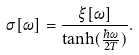<formula> <loc_0><loc_0><loc_500><loc_500>\sigma [ \omega ] = { \frac { \xi [ \omega ] } { \tanh ( { \frac { \hbar { \omega } } { 2 T } } ) } } .</formula> 